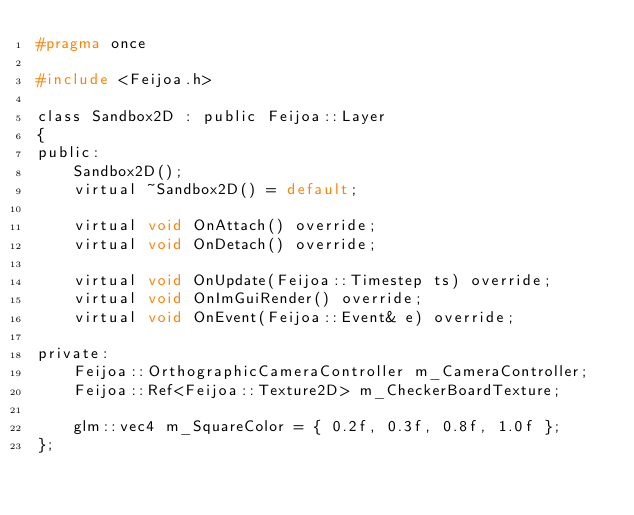<code> <loc_0><loc_0><loc_500><loc_500><_C_>#pragma once

#include <Feijoa.h>

class Sandbox2D : public Feijoa::Layer
{
public:
	Sandbox2D();
	virtual ~Sandbox2D() = default;

	virtual void OnAttach() override;
	virtual void OnDetach() override;

	virtual void OnUpdate(Feijoa::Timestep ts) override;
	virtual void OnImGuiRender() override;
	virtual void OnEvent(Feijoa::Event& e) override;

private:
	Feijoa::OrthographicCameraController m_CameraController;
	Feijoa::Ref<Feijoa::Texture2D> m_CheckerBoardTexture;

	glm::vec4 m_SquareColor = { 0.2f, 0.3f, 0.8f, 1.0f };
};</code> 